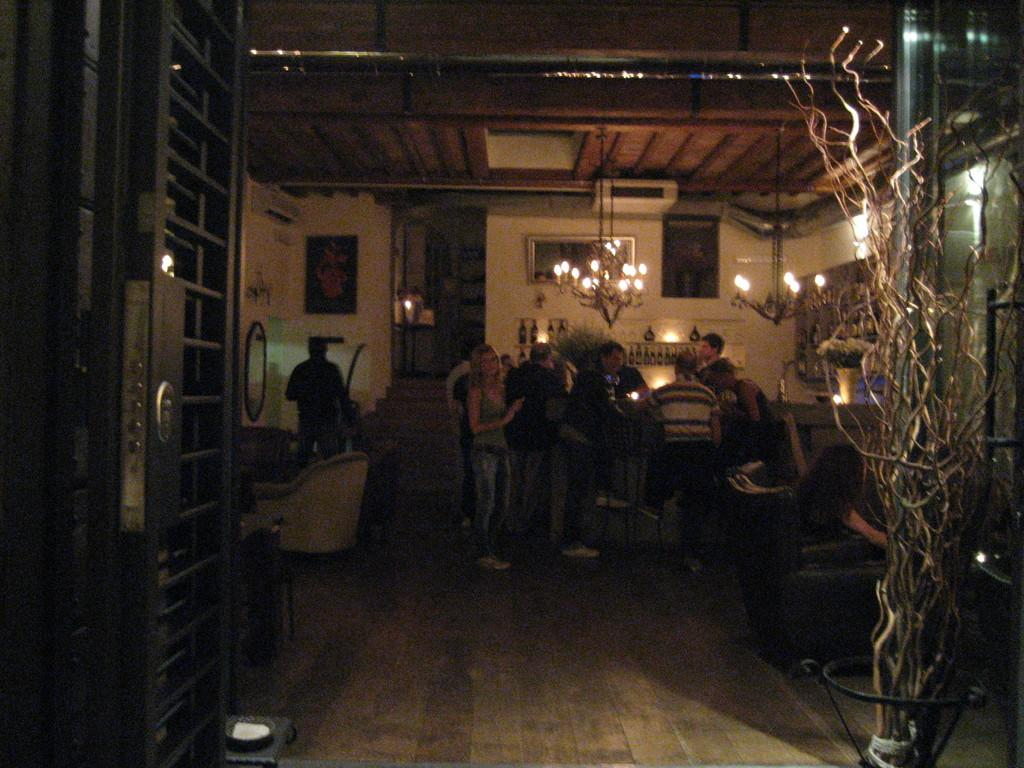How many people are in the image? There are persons in the image, but the exact number cannot be determined from the provided facts. What type of furniture is present in the image? There are chairs and tables in the image. What architectural feature can be seen in the image? There is a door in the image. What type of illumination is present in the image? There are lights in the image. What type of structure is visible in the image? There is a wall in the image. What type of flight can be seen taking off in the image? There is no flight present in the image; it only features persons, chairs, tables, a door, lights, and a wall. How many times has the shape been washed in the image? There is no shape mentioned in the image, and therefore it cannot be washed or have any washing-related actions. 